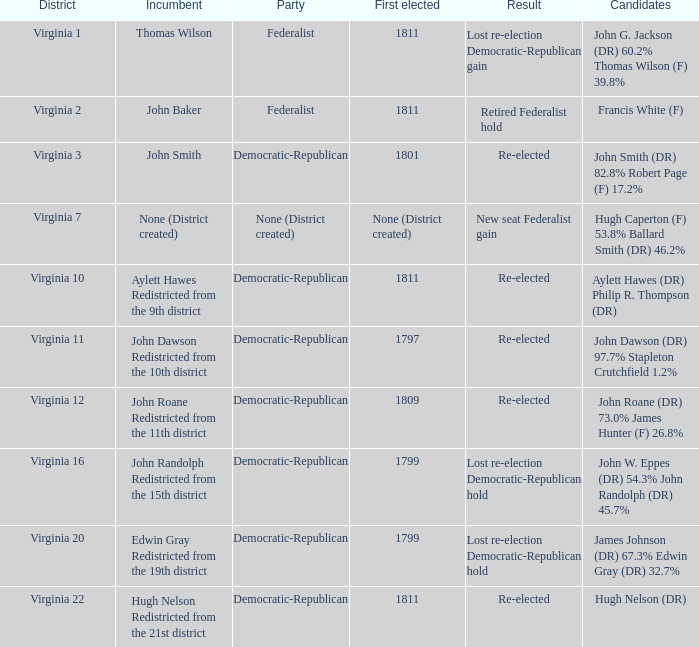What is the political party representing virginia's 12th district? Democratic-Republican. 